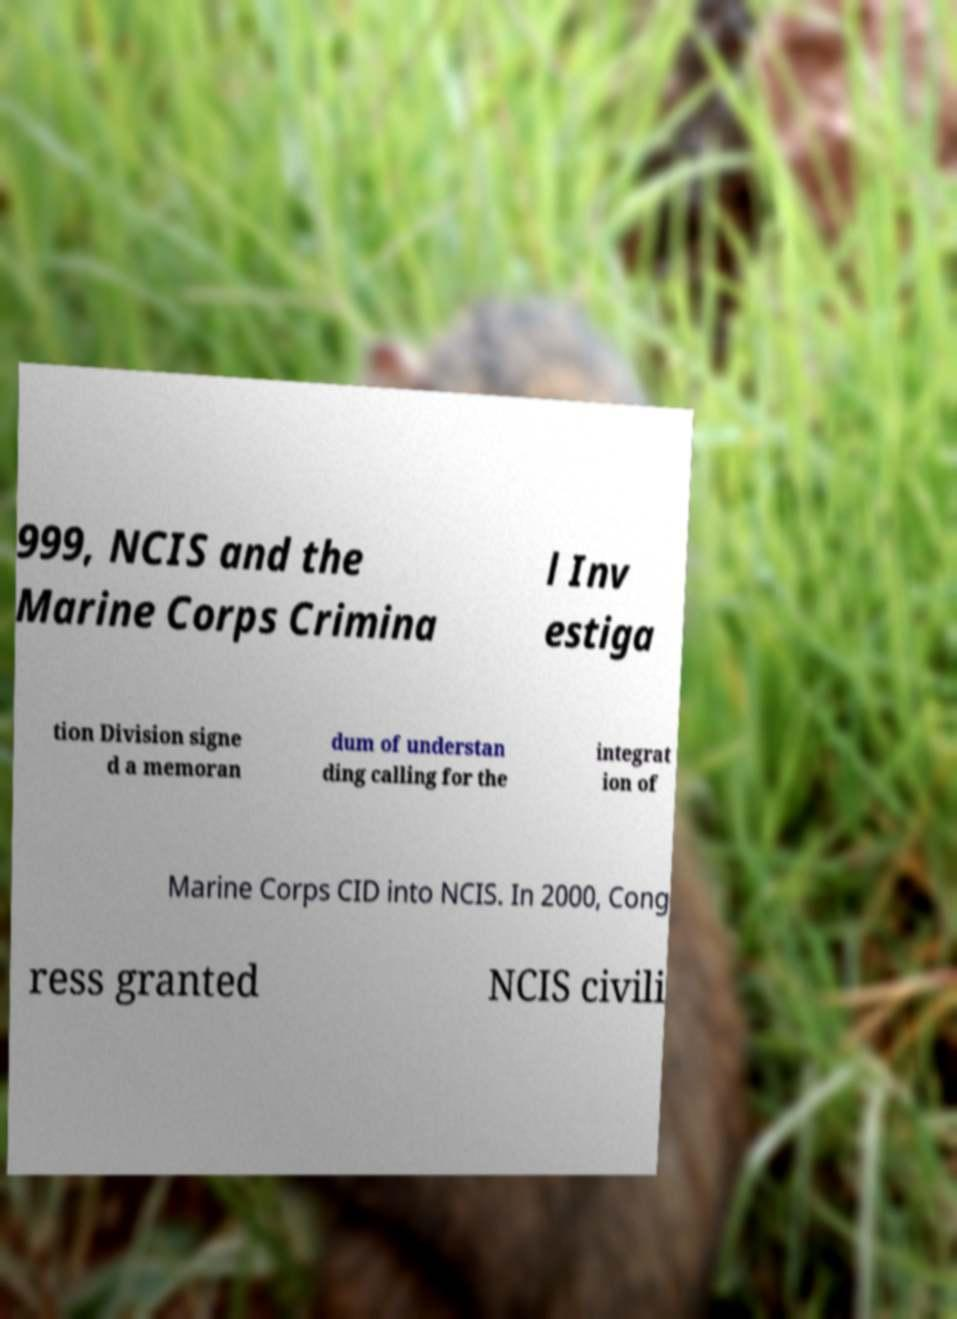There's text embedded in this image that I need extracted. Can you transcribe it verbatim? 999, NCIS and the Marine Corps Crimina l Inv estiga tion Division signe d a memoran dum of understan ding calling for the integrat ion of Marine Corps CID into NCIS. In 2000, Cong ress granted NCIS civili 